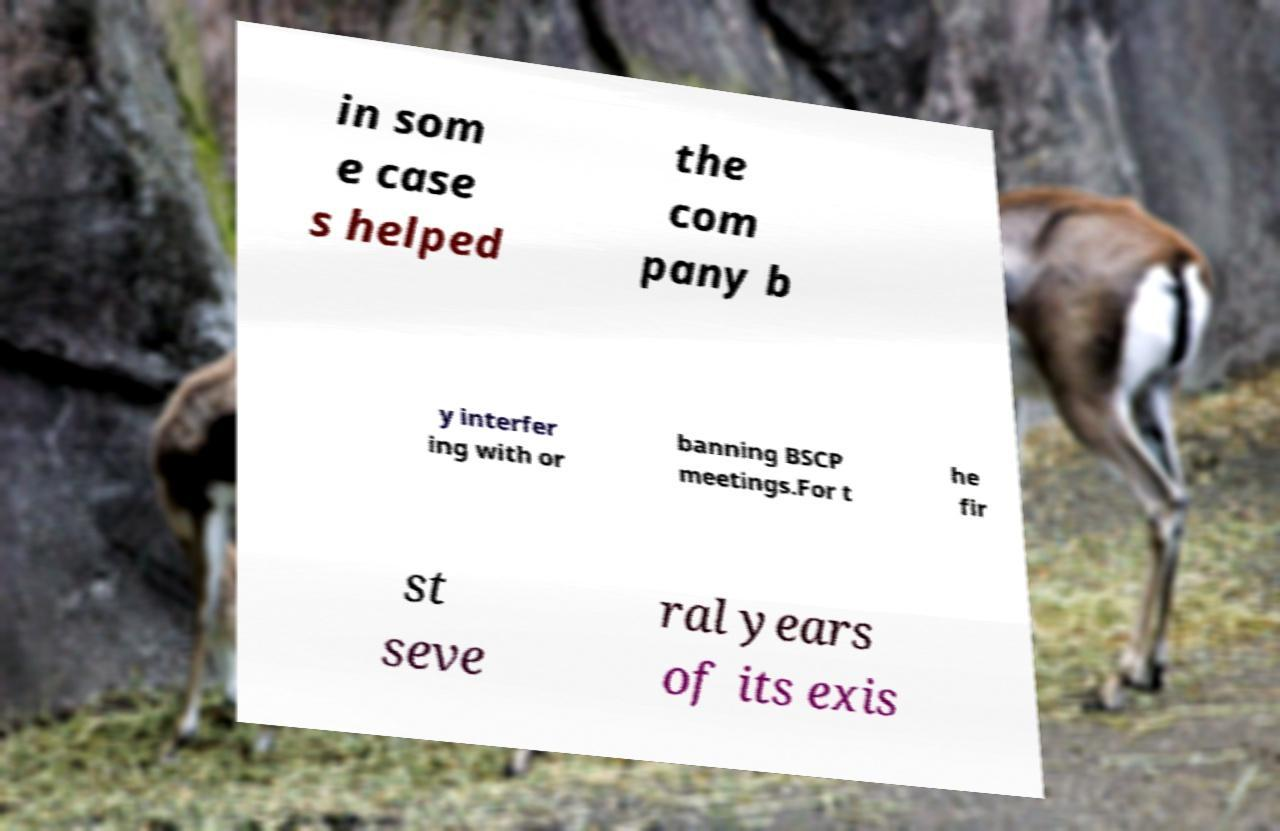Please read and relay the text visible in this image. What does it say? in som e case s helped the com pany b y interfer ing with or banning BSCP meetings.For t he fir st seve ral years of its exis 